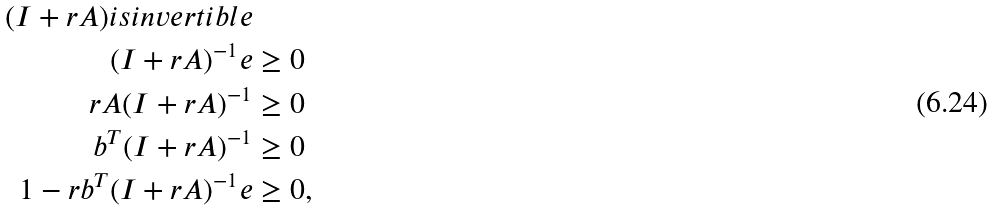<formula> <loc_0><loc_0><loc_500><loc_500>( I + r A ) i s i n v e r t i b l e & \\ ( I + r A ) ^ { - 1 } e & \geq 0 \\ r A ( I + r A ) ^ { - 1 } & \geq 0 \\ b ^ { T } ( I + r A ) ^ { - 1 } & \geq 0 \\ 1 - r b ^ { T } ( I + r A ) ^ { - 1 } e & \geq 0 ,</formula> 